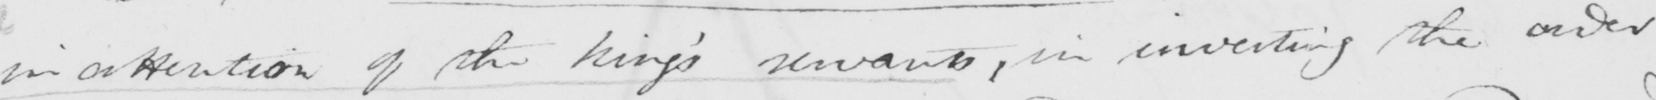Can you tell me what this handwritten text says? inattention of the king '  servants , in investing the order 